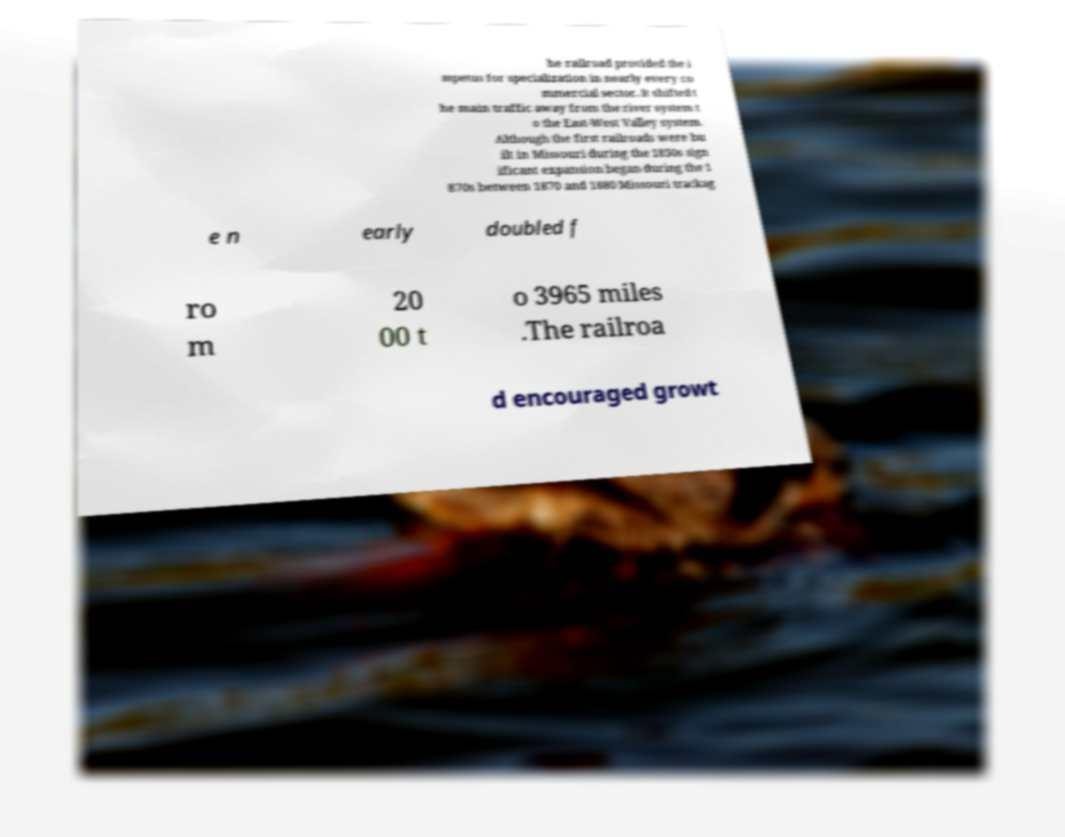Can you accurately transcribe the text from the provided image for me? he railroad provided the i mpetus for specialization in nearly every co mmercial sector. It shifted t he main traffic away from the river system t o the East-West Valley system. Although the first railroads were bu ilt in Missouri during the 1850s sign ificant expansion began during the 1 870s between 1870 and 1880 Missouri trackag e n early doubled f ro m 20 00 t o 3965 miles .The railroa d encouraged growt 